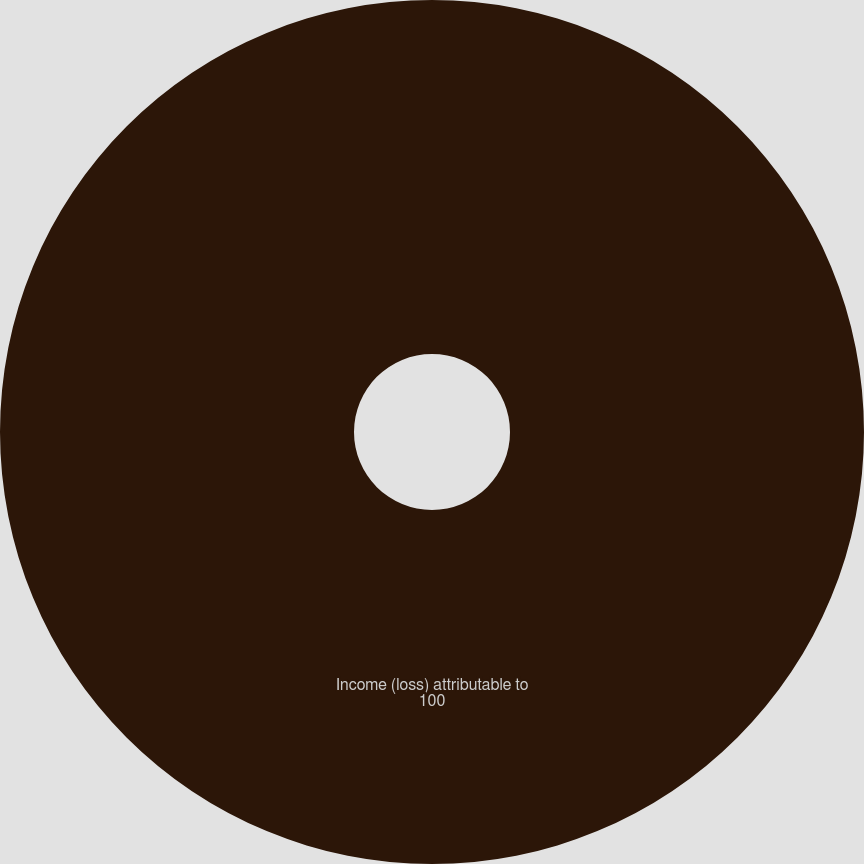<chart> <loc_0><loc_0><loc_500><loc_500><pie_chart><fcel>Income (loss) attributable to<nl><fcel>100.0%<nl></chart> 